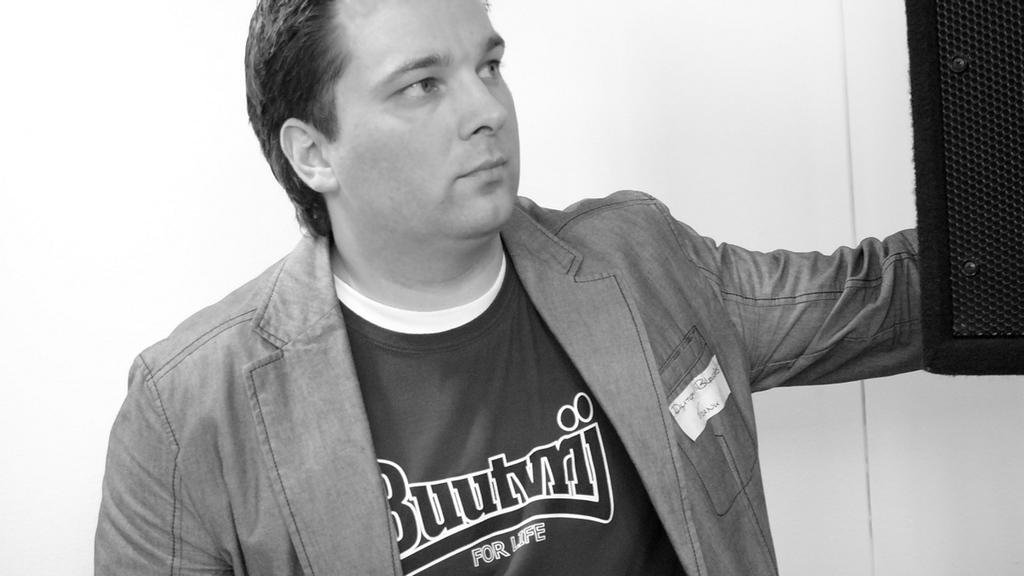<image>
Provide a brief description of the given image. A man wearing a Buutvrij shirt and a jacket standing in a room. 